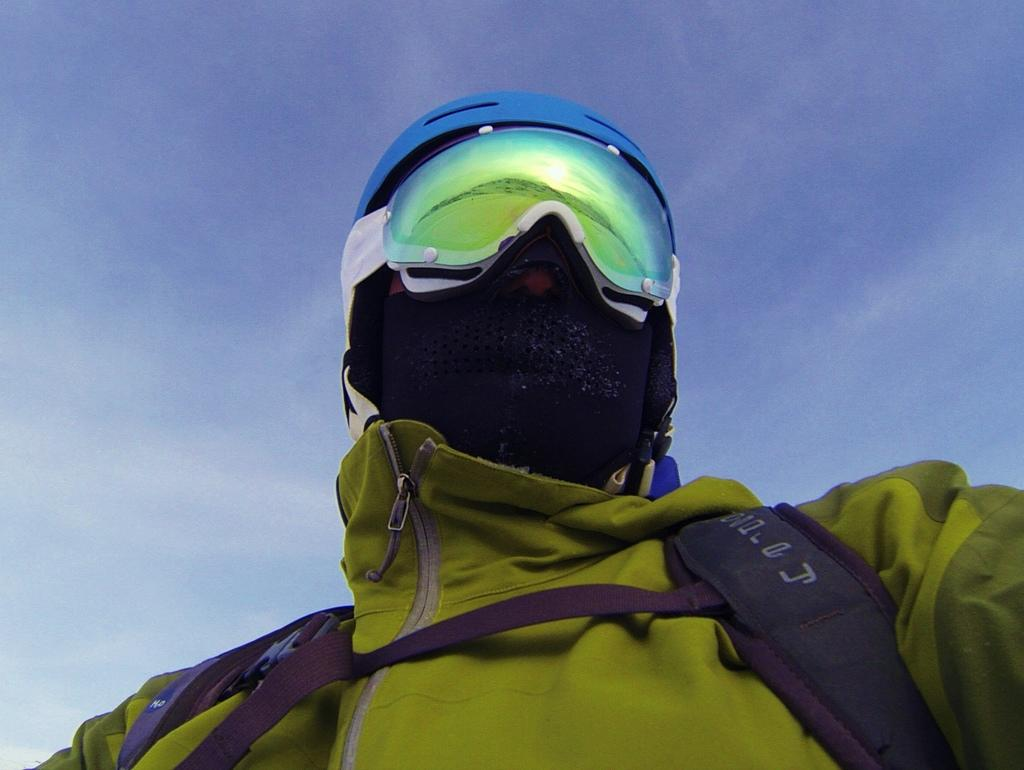Who or what is present in the image? There is a person in the image. What is the person wearing on their head? The person is wearing a helmet. What can be seen in the background of the image? There is sky visible in the background of the image. What type of vegetable is the person holding in the image? There is no vegetable present in the image; the person is wearing a helmet. Can you tell me how many cups are visible in the image? There are no cups visible in the image. 